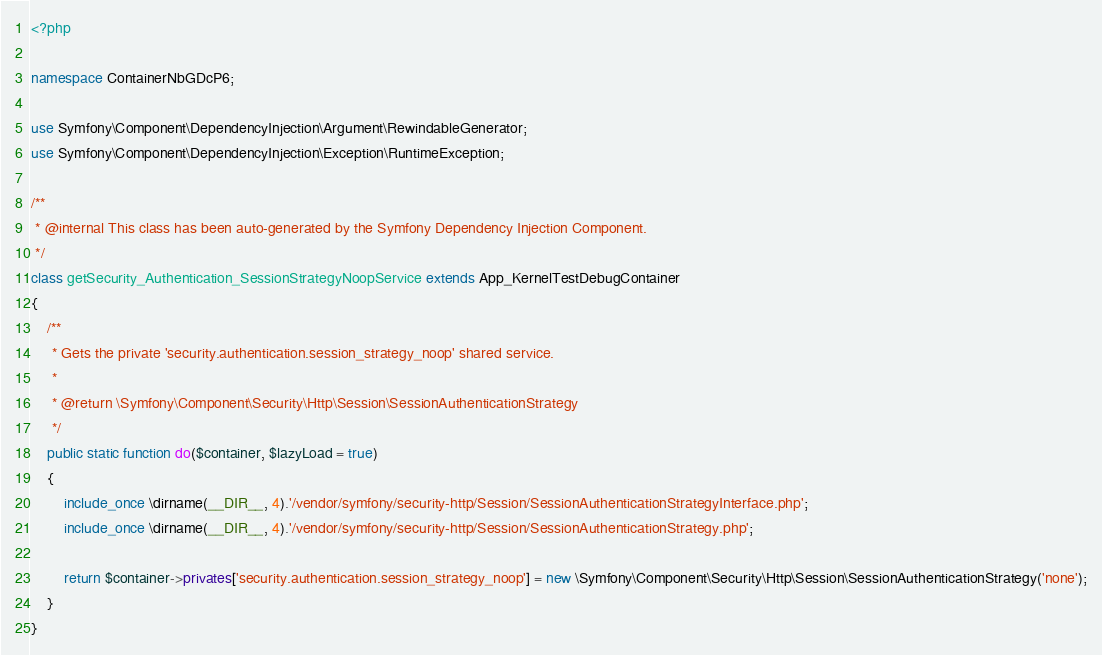<code> <loc_0><loc_0><loc_500><loc_500><_PHP_><?php

namespace ContainerNbGDcP6;

use Symfony\Component\DependencyInjection\Argument\RewindableGenerator;
use Symfony\Component\DependencyInjection\Exception\RuntimeException;

/**
 * @internal This class has been auto-generated by the Symfony Dependency Injection Component.
 */
class getSecurity_Authentication_SessionStrategyNoopService extends App_KernelTestDebugContainer
{
    /**
     * Gets the private 'security.authentication.session_strategy_noop' shared service.
     *
     * @return \Symfony\Component\Security\Http\Session\SessionAuthenticationStrategy
     */
    public static function do($container, $lazyLoad = true)
    {
        include_once \dirname(__DIR__, 4).'/vendor/symfony/security-http/Session/SessionAuthenticationStrategyInterface.php';
        include_once \dirname(__DIR__, 4).'/vendor/symfony/security-http/Session/SessionAuthenticationStrategy.php';

        return $container->privates['security.authentication.session_strategy_noop'] = new \Symfony\Component\Security\Http\Session\SessionAuthenticationStrategy('none');
    }
}
</code> 